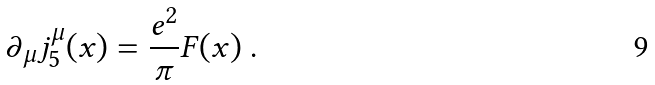Convert formula to latex. <formula><loc_0><loc_0><loc_500><loc_500>\partial _ { \mu } j _ { 5 } ^ { \mu } ( x ) = \frac { e ^ { 2 } } { \pi } F ( x ) \ .</formula> 